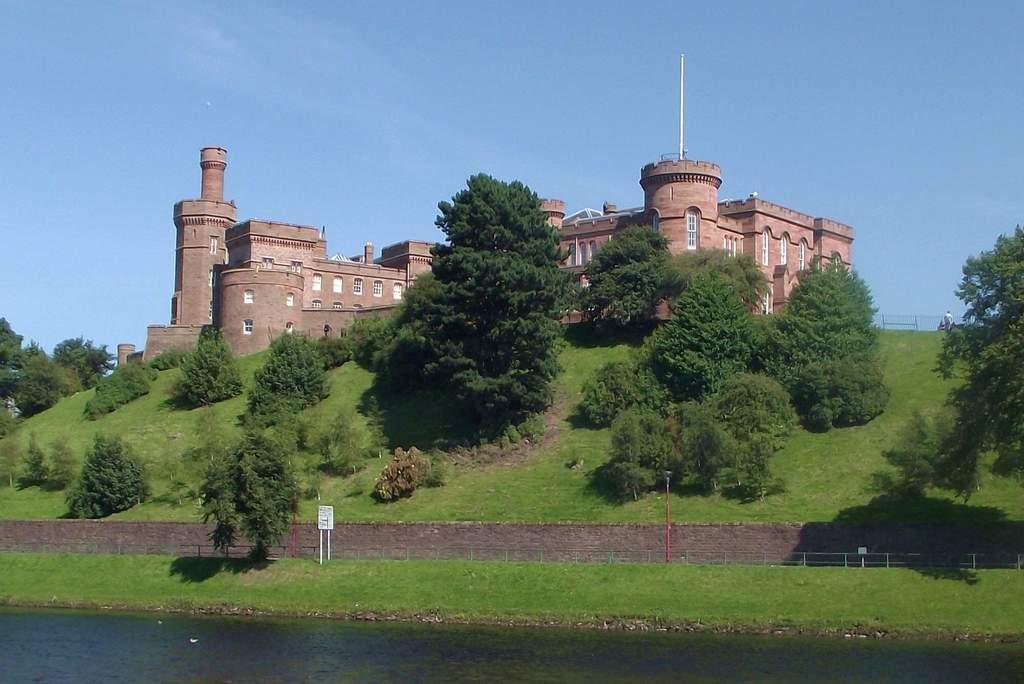What is the primary element visible in the image? There is water in the image. What type of structure can be seen in the image? There is a sign board in the image. What type of vegetation is present in the image? There is grass and trees in the image. What can be seen in the background of the image? There is a fort and clouds visible in the background of the image. What type of breakfast is being served in the image? There is no breakfast present in the image. How many apples are visible in the image? There are no apples present in the image. 